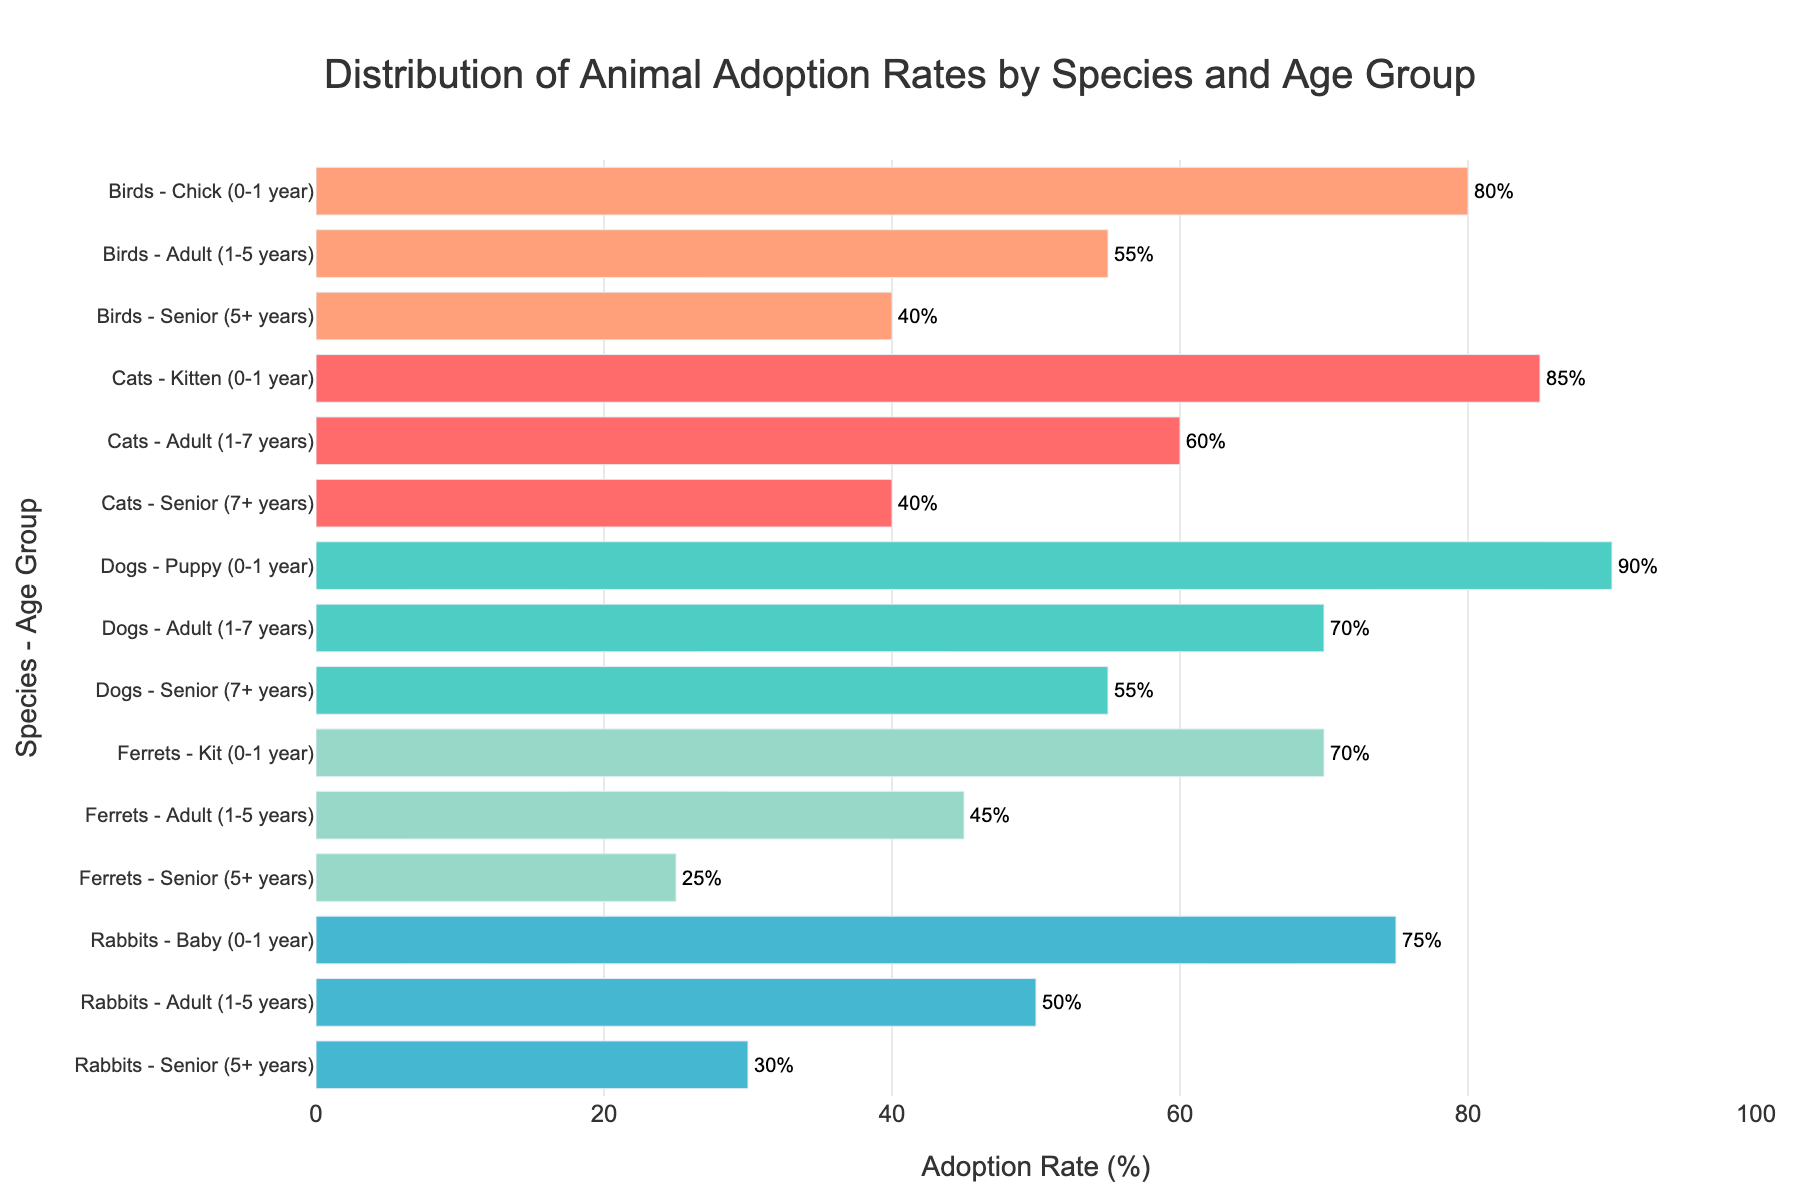Which age group of cats has the highest adoption rate? The figure shows different age groups for cats with their respective adoption rates. By comparing them, we see that the "Kitten (0-1 year)" group has the highest adoption rate at 85%.
Answer: Kitten (0-1 year) What is the difference in adoption rate between senior dogs and senior ferrets? From the figure, the adoption rate for senior dogs is 55% and for senior ferrets is 25%. The difference is calculated as 55% - 25% = 30%.
Answer: 30% Among the given species, which has the lowest adoption rate for any age group? By scanning the bars for the lowest values, we see that senior ferrets have the lowest adoption rate at 25%.
Answer: Ferrets How does the adoption rate of adult rabbits compare to that of adult birds? The figure indicates that adult rabbits have an adoption rate of 50%, while adult birds have an adoption rate of 55%. Therefore, adult birds have a slightly higher adoption rate.
Answer: Birds What is the average adoption rate for all adult animals across different species? To find the average, sum the adoption rates for adult animals across all species and divide by the number of species: (60% + 70% + 50% + 55% + 45%) / 5 = 280% / 5 = 56%.
Answer: 56% Which species has the largest variation in adoption rates between its age groups? To find this, look at the differences in adoption rates between the highest and lowest age groups for each species. Cats: 85% - 40% = 45%, Dogs: 90% - 55% = 35%, Rabbits: 75% - 30% = 45%, Birds: 80% - 40% = 40%, Ferrets: 70% - 25% = 45%. Cats, Rabbits, and Ferrets each have a variation of 45%.
Answer: Cats, Rabbits, Ferrets What is the combined adoption rate of baby and senior rabbits? The figure shows baby rabbits with an adoption rate of 75% and senior rabbits at 30%. Adding these rates together gives 75% + 30% = 105%.
Answer: 105% Which species has the most uniform adoption rates across all its age groups? By evaluating the consistency of the adoption rates, dogs show the most uniform rates: 90% for puppies, 70% for adults, and 55% for seniors. The differences between their age groups are relatively small compared to other species.
Answer: Dogs 